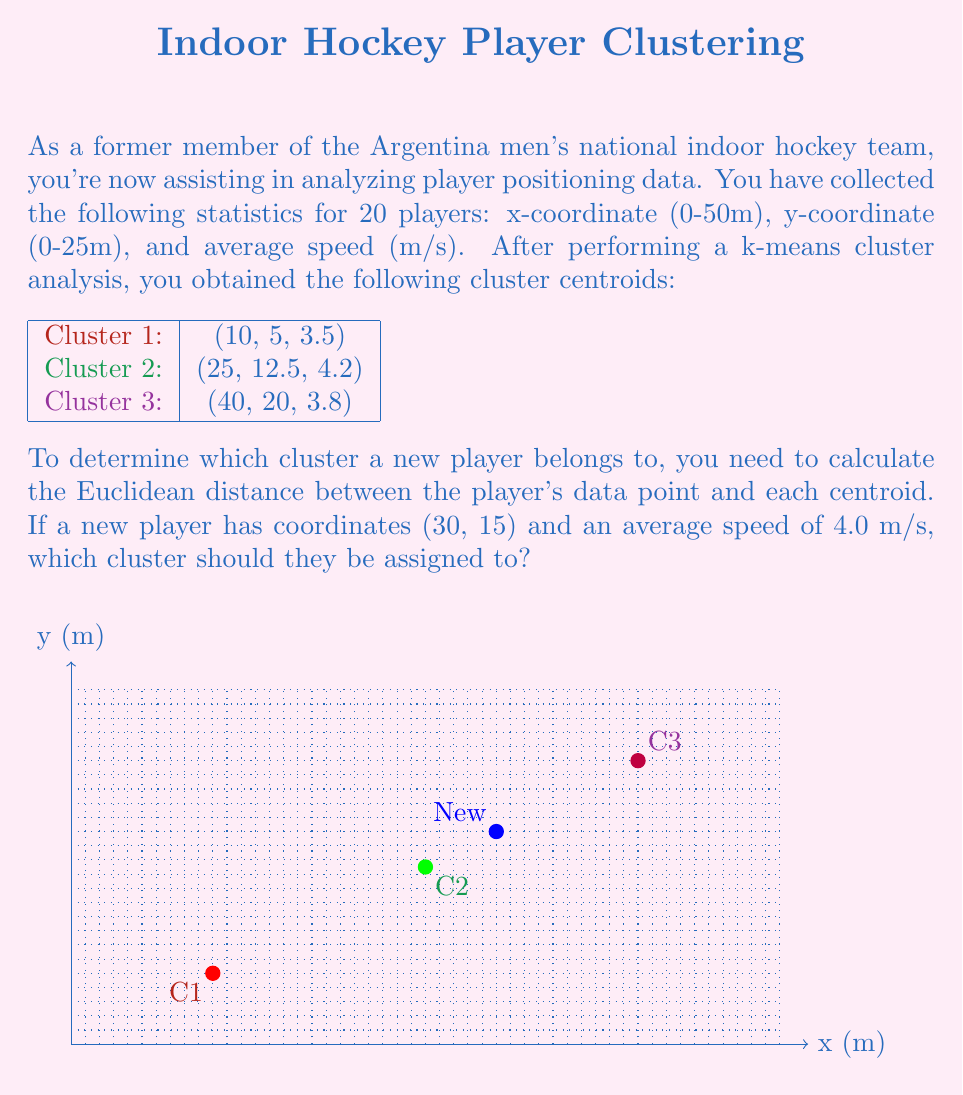What is the answer to this math problem? To solve this problem, we need to calculate the Euclidean distance between the new player's data point and each cluster centroid. The Euclidean distance in 3D space is given by:

$$ d = \sqrt{(x_2 - x_1)^2 + (y_2 - y_1)^2 + (z_2 - z_1)^2} $$

Where $(x_1, y_1, z_1)$ is the centroid and $(x_2, y_2, z_2)$ is the new player's data point.

Step 1: Calculate the distance to Cluster 1 centroid (10, 5, 3.5)
$$ d_1 = \sqrt{(30 - 10)^2 + (15 - 5)^2 + (4.0 - 3.5)^2} $$
$$ d_1 = \sqrt{400 + 100 + 0.25} = \sqrt{500.25} \approx 22.37 $$

Step 2: Calculate the distance to Cluster 2 centroid (25, 12.5, 4.2)
$$ d_2 = \sqrt{(30 - 25)^2 + (15 - 12.5)^2 + (4.0 - 4.2)^2} $$
$$ d_2 = \sqrt{25 + 6.25 + 0.04} = \sqrt{31.29} \approx 5.59 $$

Step 3: Calculate the distance to Cluster 3 centroid (40, 20, 3.8)
$$ d_3 = \sqrt{(30 - 40)^2 + (15 - 20)^2 + (4.0 - 3.8)^2} $$
$$ d_3 = \sqrt{100 + 25 + 0.04} = \sqrt{125.04} \approx 11.18 $$

Step 4: Compare the distances
The smallest distance is $d_2 \approx 5.59$, which corresponds to Cluster 2.

Therefore, the new player should be assigned to Cluster 2.
Answer: Cluster 2 